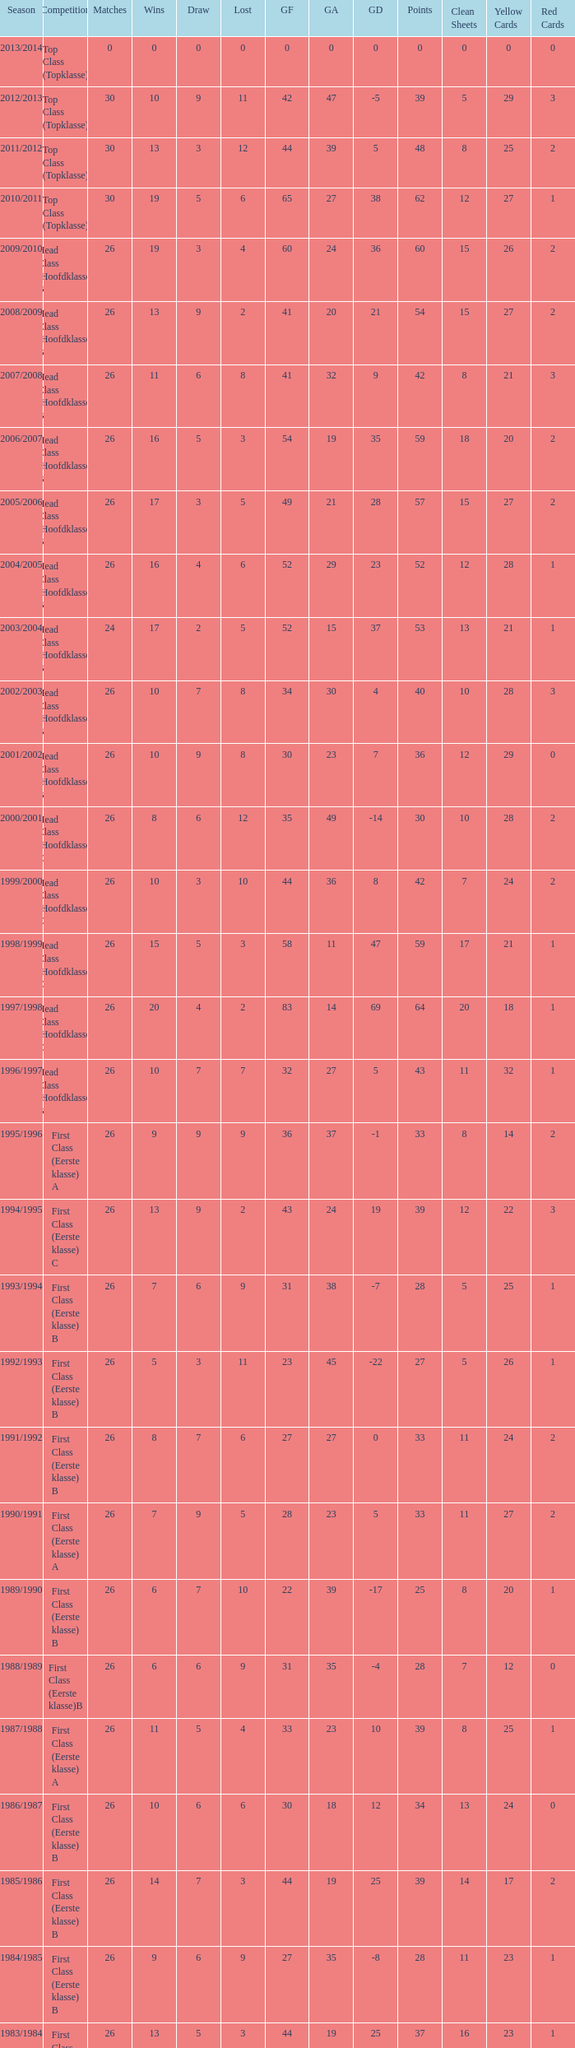What is the total number of matches with a loss less than 5 in the 2008/2009 season and has a draw larger than 9? 0.0. 